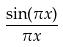<formula> <loc_0><loc_0><loc_500><loc_500>\frac { \sin ( \pi x ) } { \pi x }</formula> 